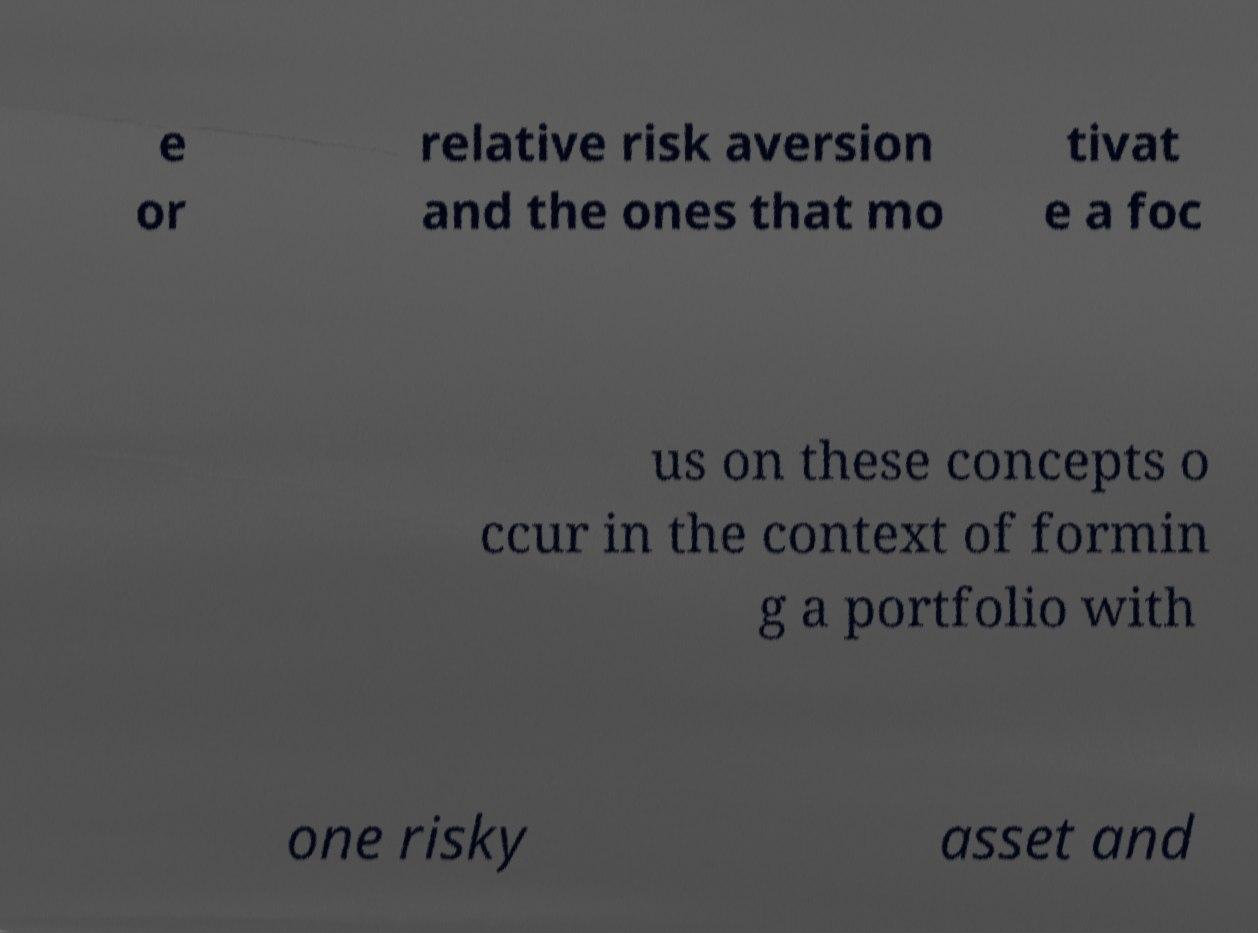Please identify and transcribe the text found in this image. e or relative risk aversion and the ones that mo tivat e a foc us on these concepts o ccur in the context of formin g a portfolio with one risky asset and 